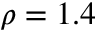<formula> <loc_0><loc_0><loc_500><loc_500>\rho = 1 . 4</formula> 